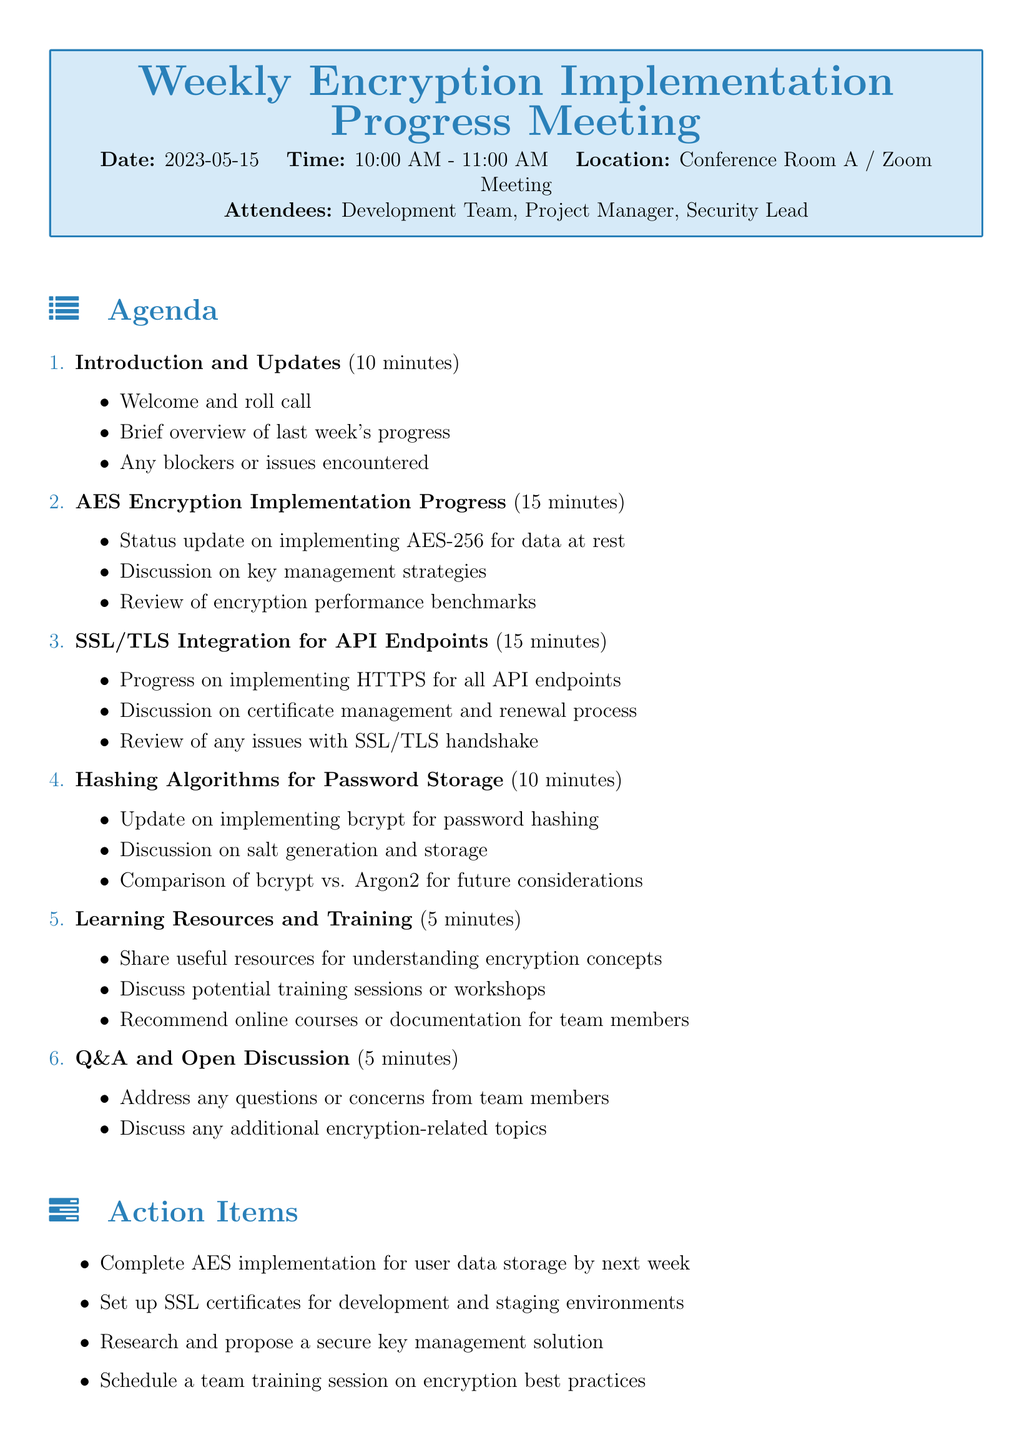What is the meeting title? The title of the meeting is mentioned in the document.
Answer: Weekly Encryption Implementation Progress Meeting What is the date of the meeting? The date is explicitly stated in the document.
Answer: 2023-05-15 How long is the AES encryption implementation discussion scheduled for? The duration for discussing AES encryption is noted in the agenda items section.
Answer: 15 minutes Which encryption algorithm is being implemented for password hashing? The document specifies the algorithm for password storage.
Answer: bcrypt How many attendees are listed for the meeting? The number of attendees can be counted from the list provided in the document.
Answer: 3 What action is required for SSL certificates? The document outlines a specific action item related to SSL certificates.
Answer: Set up SSL certificates for development and staging environments What is the main focus of the last agenda item? The last agenda item is described in the document.
Answer: Q&A and Open Discussion Which online course is recommended for encryption training? The resources section lists recommended training options.
Answer: Coursera Cryptography I by Stanford University What is the first agenda item mentioned? The first item in the agenda gives its title in the document.
Answer: Introduction and Updates 